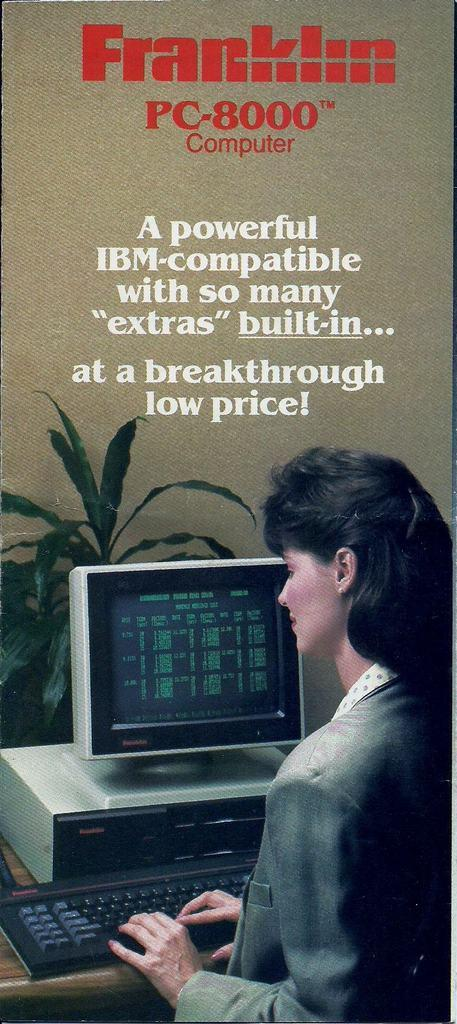What is the main subject of the image? The main subject of the image is an advertisement. Can you describe what is happening in the advertisement? Yes, there is a picture of a woman working at a desktop in the image. What type of leaf is being used as a currency in the image? There is no leaf being used as a currency in the image. What flavor of cent can be seen in the image? There is no cent present in the image, and therefore no flavor can be determined. 